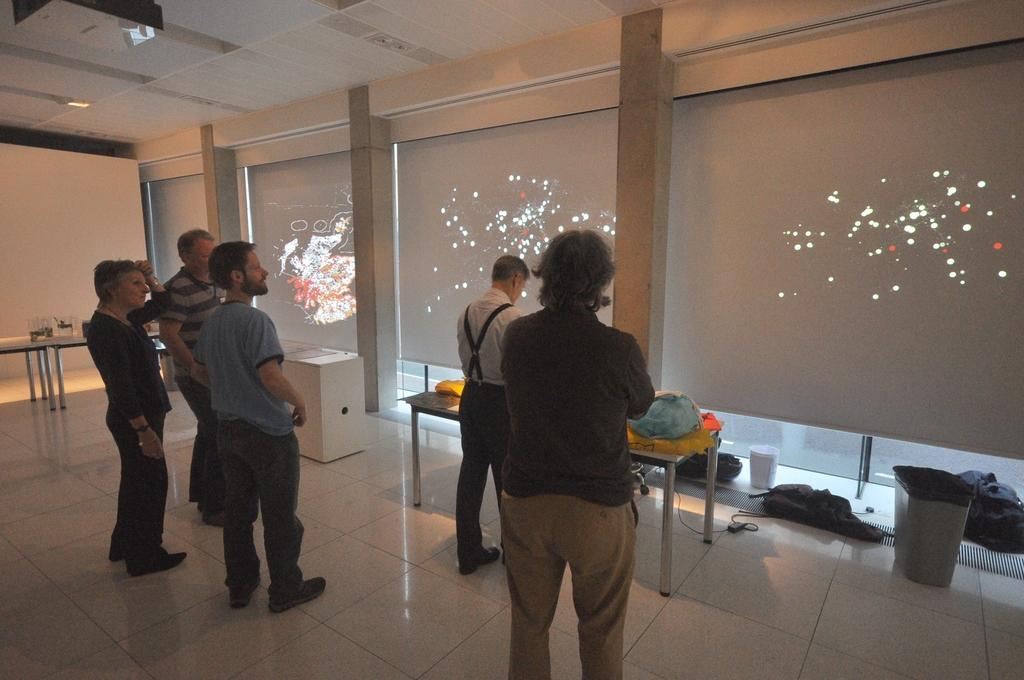What can be seen in the image involving people? There are people standing in the image. What type of decorations are present in the image? There are colorful posters in the image. What object is on a table in the image? There is a jar on a table in the image. What else is on the table in the image besides the jar? There are unspecified things on the table in the image. What is on the floor in the image? There is a bin on the floor in the image. Can you tell me how many people are swimming in the image? There is no swimming activity depicted in the image; people are standing. What type of cast is present in the image? There is no cast present in the image. 